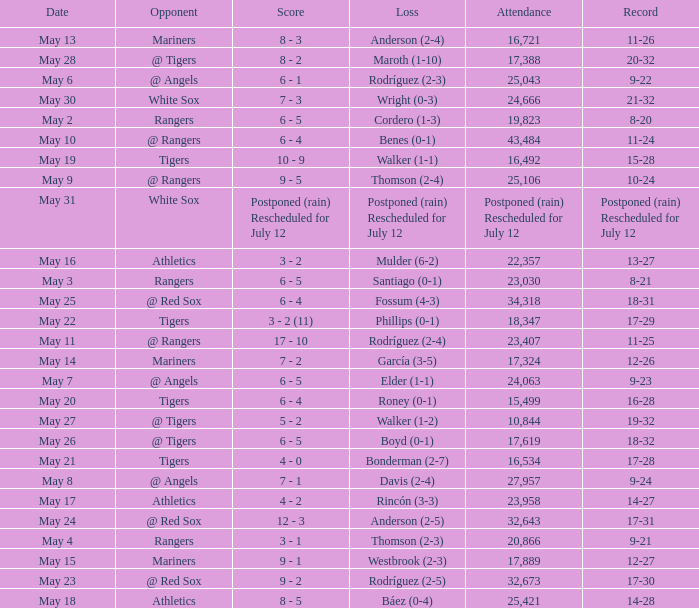What date did the Indians have a record of 14-28? May 18. 